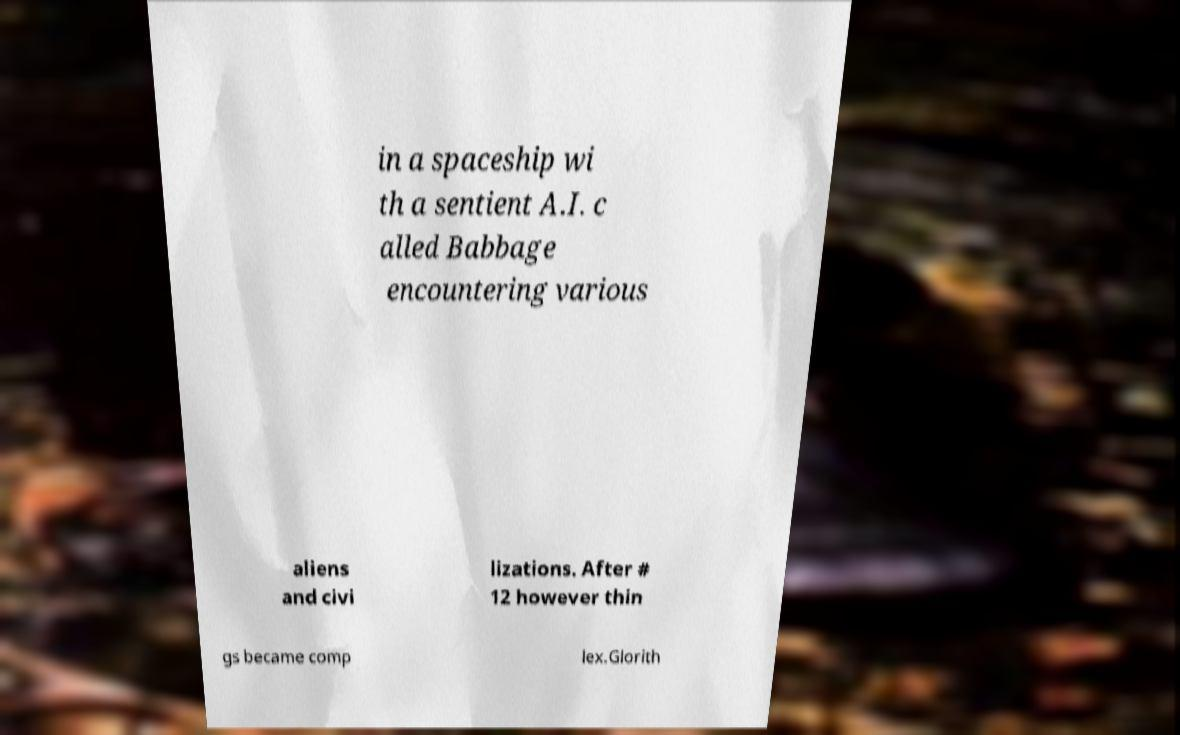For documentation purposes, I need the text within this image transcribed. Could you provide that? in a spaceship wi th a sentient A.I. c alled Babbage encountering various aliens and civi lizations. After # 12 however thin gs became comp lex.Glorith 